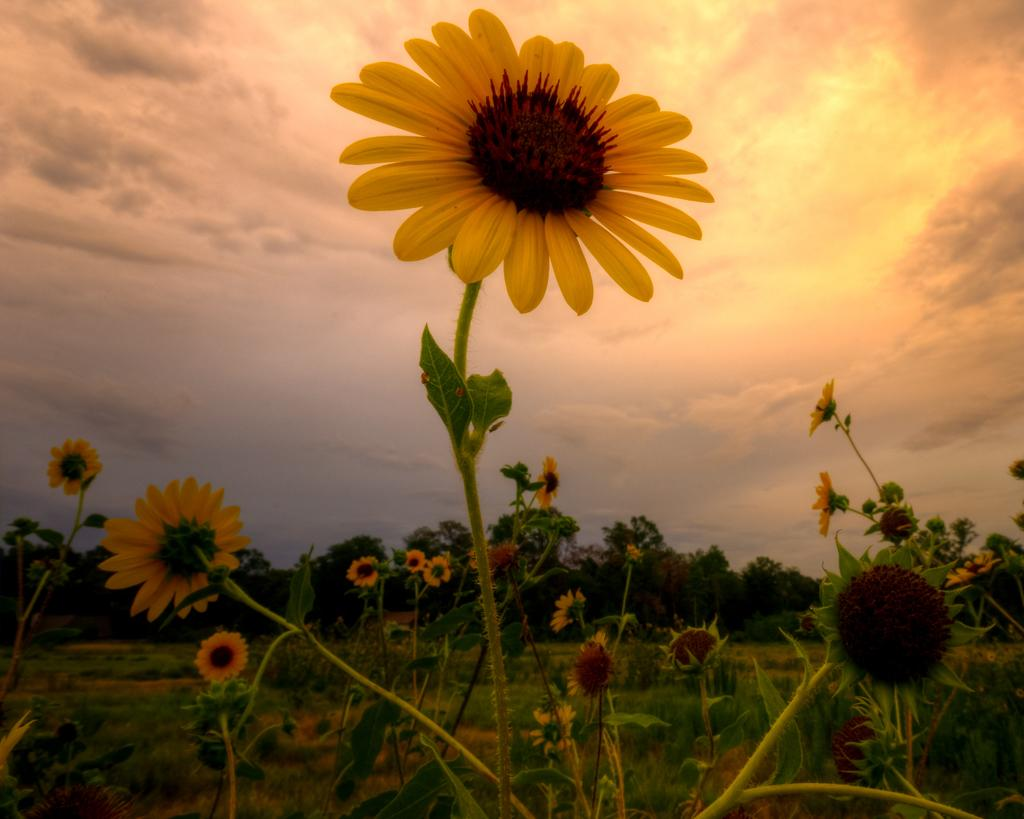What type of plants can be seen in the farmland in the image? There are sunflowers in the farmland in the image. What can be seen in the background of the image? There are many trees in the background. What is visible at the top of the image? The sky is visible at the top of the image. What can be observed in the sky? Clouds are present in the sky. What color of paint is being used to decorate the clam in the image? There is no clam present in the image, and therefore no paint or decoration can be observed. 